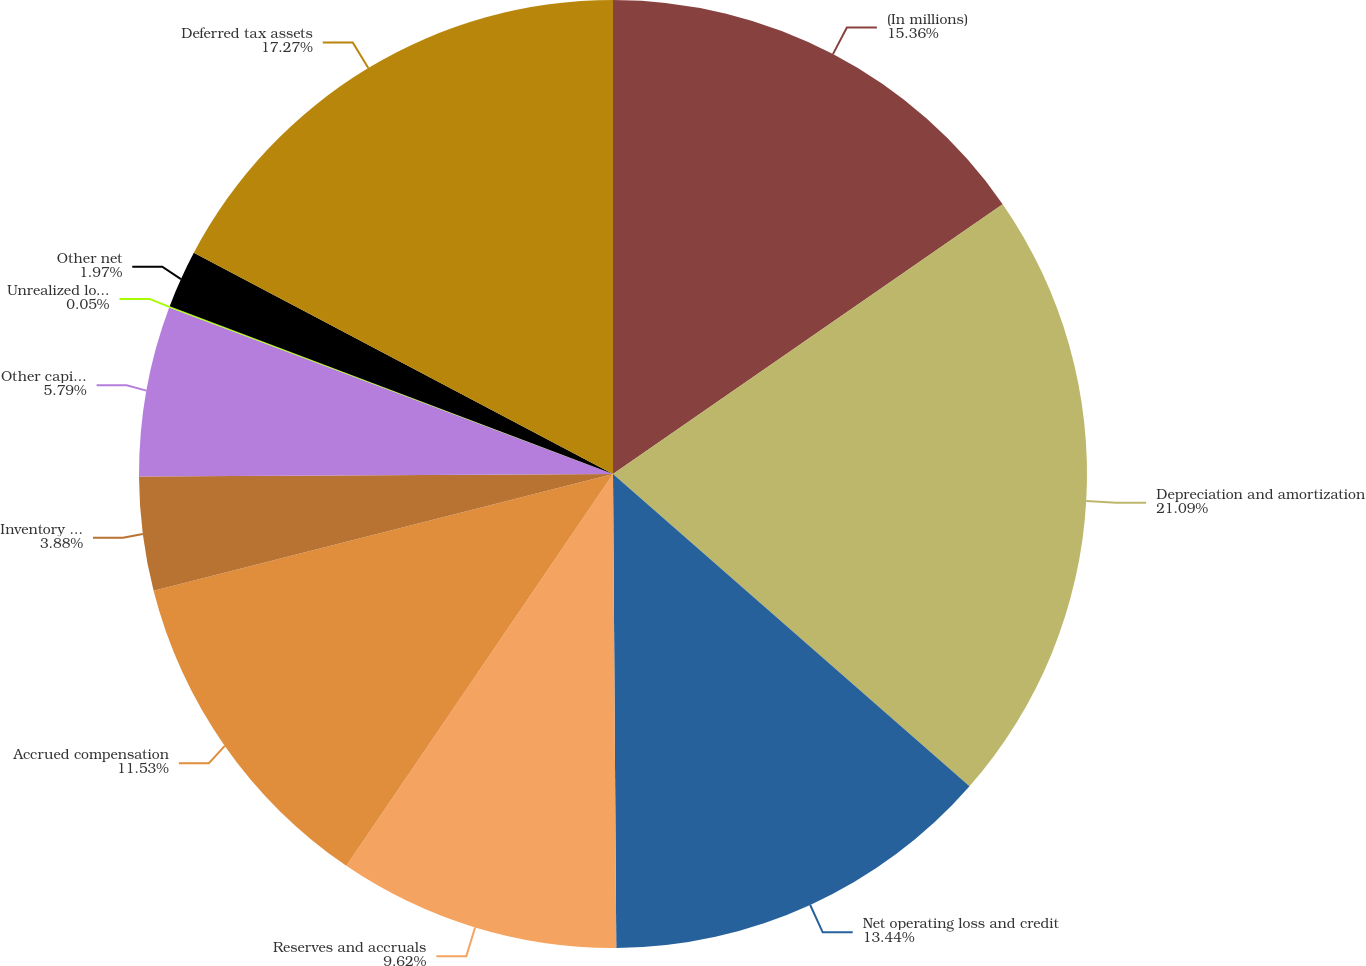<chart> <loc_0><loc_0><loc_500><loc_500><pie_chart><fcel>(In millions)<fcel>Depreciation and amortization<fcel>Net operating loss and credit<fcel>Reserves and accruals<fcel>Accrued compensation<fcel>Inventory basis difference<fcel>Other capitalized costs<fcel>Unrealized losses on hedging<fcel>Other net<fcel>Deferred tax assets<nl><fcel>15.36%<fcel>21.09%<fcel>13.44%<fcel>9.62%<fcel>11.53%<fcel>3.88%<fcel>5.79%<fcel>0.05%<fcel>1.97%<fcel>17.27%<nl></chart> 